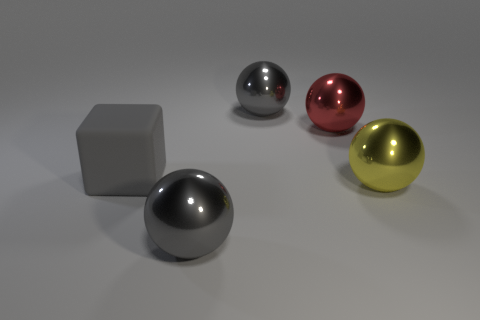Is there anything else that has the same material as the big gray cube?
Ensure brevity in your answer.  No. Do the large gray object behind the big gray matte object and the gray rubber thing have the same shape?
Offer a very short reply. No. There is a big gray block in front of the large red object; what is it made of?
Make the answer very short. Rubber. Are there any small green cubes that have the same material as the big red object?
Provide a succinct answer. No. What size is the yellow sphere?
Your response must be concise. Large. How many brown things are either small metal cubes or large shiny spheres?
Provide a succinct answer. 0. How many gray metal things are the same shape as the yellow thing?
Keep it short and to the point. 2. How many gray metallic objects are the same size as the red thing?
Make the answer very short. 2. What is the material of the yellow thing that is the same shape as the large red thing?
Your answer should be compact. Metal. There is a large rubber cube behind the yellow ball; what is its color?
Ensure brevity in your answer.  Gray. 